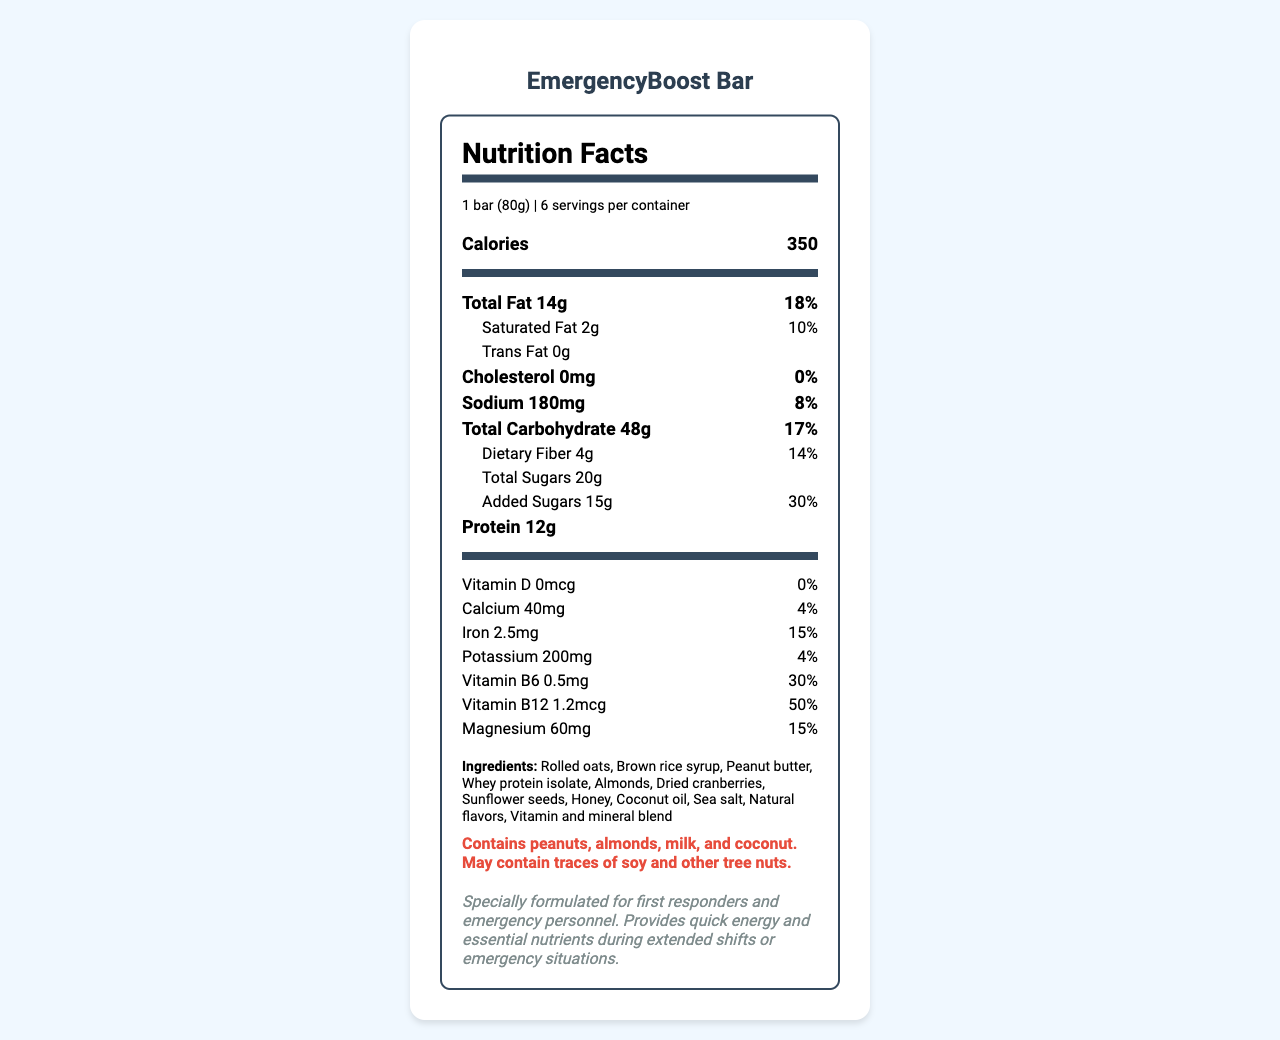what is the serving size of the EmergencyBoost Bar? The document mentions that the serving size is "1 bar (80g)".
Answer: 1 bar (80g) how many servings are there per container? The document states there are 6 servings per container.
Answer: 6 how much sodium is in one serving of the EmergencyBoost Bar? The document lists Sodium as 180mg per serving.
Answer: 180mg how much protein is there in one EmergencyBoost Bar? The document states that each bar contains 12g of protein.
Answer: 12g is there any cholesterol in the EmergencyBoost Bar? The document shows that the amount of cholesterol is 0mg.
Answer: 0mg how much of the daily value for Vitamin B12 does one bar provide? A. 15% B. 30% C. 50% D. 100% The document indicates that each bar provides 50% of the daily value for Vitamin B12.
Answer: C. 50% which certification does the EmergencyBoost Bar have? A. USDA Organic B. Non-GMO Project Verified C. Fair Trade Certified D. Certified Vegan The document says the product is Non-GMO Project Verified.
Answer: B. Non-GMO Project Verified should I store the EmergencyBoost Bar in a moist, warm place? The document advises to "Store in a cool, dry place."
Answer: No does the EmergencyBoost Bar contain peanuts? The document lists "Contains peanuts" in the allergen information section.
Answer: Yes what is the main idea of the document? The document includes a comprehensive Nutrition Facts label, ingredients list, allergen information, and additional notes about the product's design and storage.
Answer: The document provides detailed nutritional information about the EmergencyBoost Bar, a high-energy snack designed for first responders, listing its nutrients, ingredients, certifications, and storage instructions. what is the EmergencyBoost Bar's shelf life? The document does not provide explicit information about the shelf life, only storage recommendations.
Answer: Not enough information compare the amount of total sugars and added sugars in the EmergencyBoost Bar. The document shows that the bar has 20g of total sugars and 15g of added sugars.
Answer: Total Sugars: 20g, Added Sugars: 15g 